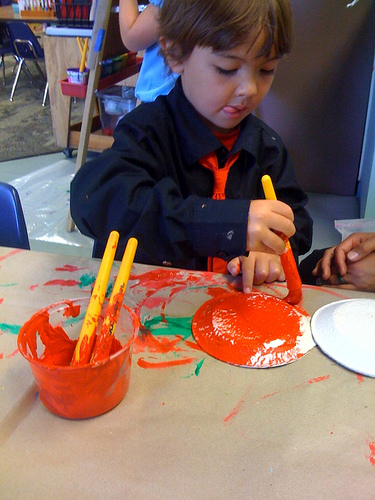How many cups are in the photo? 1 